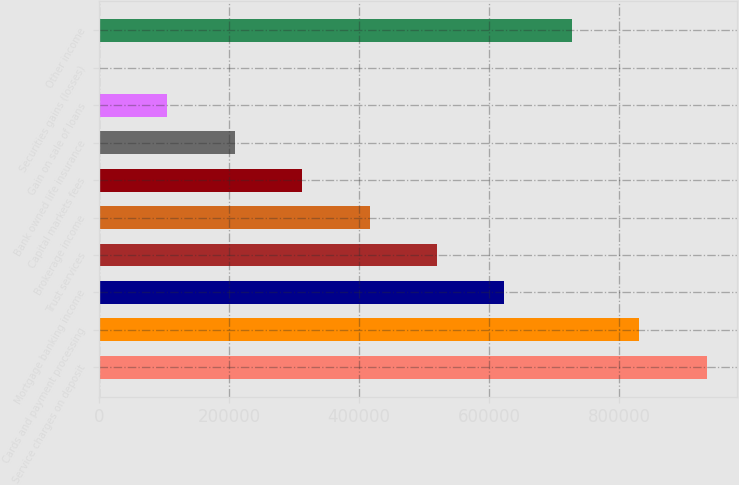<chart> <loc_0><loc_0><loc_500><loc_500><bar_chart><fcel>Service charges on deposit<fcel>Cards and payment processing<fcel>Mortgage banking income<fcel>Trust services<fcel>Brokerage income<fcel>Capital markets fees<fcel>Bank owned life insurance<fcel>Gain on sale of loans<fcel>Securities gains (losses)<fcel>Other income<nl><fcel>934931<fcel>831133<fcel>623536<fcel>519737<fcel>415938<fcel>312140<fcel>208341<fcel>104543<fcel>744<fcel>727334<nl></chart> 